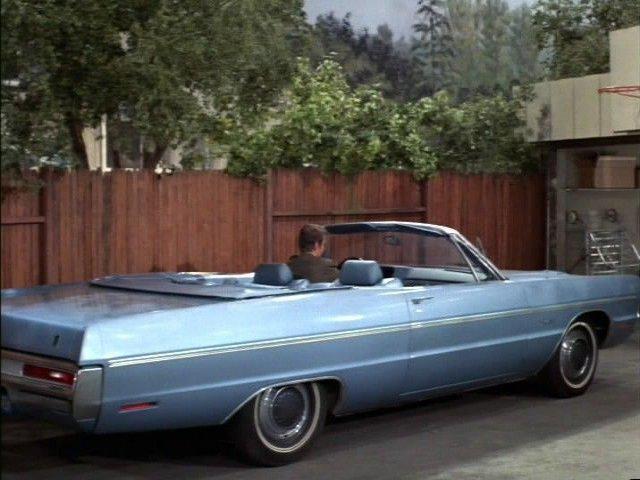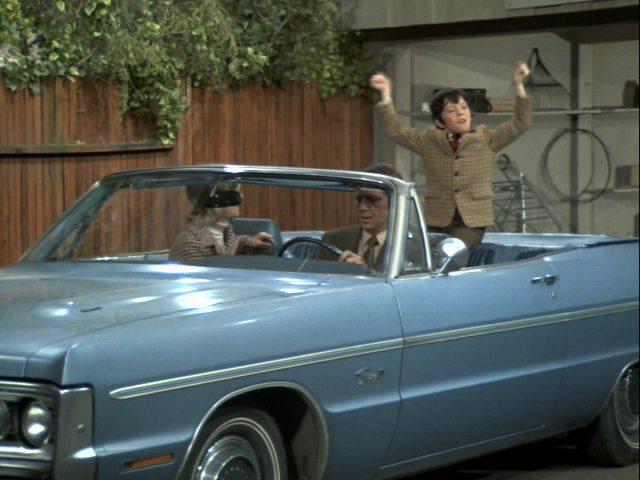The first image is the image on the left, the second image is the image on the right. Considering the images on both sides, is "A man in a brown suit is standing." valid? Answer yes or no. Yes. The first image is the image on the left, the second image is the image on the right. Examine the images to the left and right. Is the description "There is more than one person in one of the cars." accurate? Answer yes or no. Yes. 